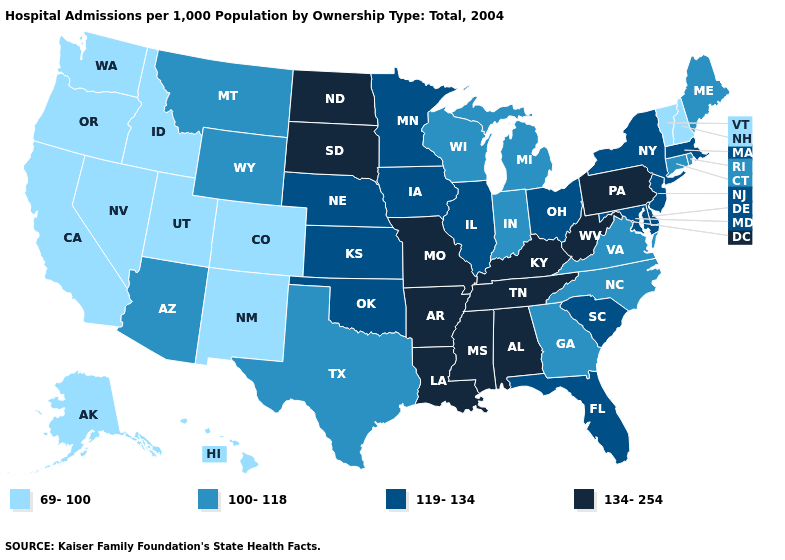Which states have the highest value in the USA?
Quick response, please. Alabama, Arkansas, Kentucky, Louisiana, Mississippi, Missouri, North Dakota, Pennsylvania, South Dakota, Tennessee, West Virginia. Which states have the lowest value in the West?
Short answer required. Alaska, California, Colorado, Hawaii, Idaho, Nevada, New Mexico, Oregon, Utah, Washington. Does Mississippi have the lowest value in the USA?
Short answer required. No. What is the highest value in states that border Oregon?
Answer briefly. 69-100. Which states have the highest value in the USA?
Write a very short answer. Alabama, Arkansas, Kentucky, Louisiana, Mississippi, Missouri, North Dakota, Pennsylvania, South Dakota, Tennessee, West Virginia. Is the legend a continuous bar?
Keep it brief. No. Among the states that border Wyoming , does Nebraska have the lowest value?
Keep it brief. No. What is the highest value in the USA?
Short answer required. 134-254. Name the states that have a value in the range 119-134?
Give a very brief answer. Delaware, Florida, Illinois, Iowa, Kansas, Maryland, Massachusetts, Minnesota, Nebraska, New Jersey, New York, Ohio, Oklahoma, South Carolina. What is the value of Ohio?
Be succinct. 119-134. What is the value of California?
Quick response, please. 69-100. Does Iowa have a lower value than Idaho?
Answer briefly. No. What is the lowest value in states that border Oregon?
Be succinct. 69-100. Which states have the highest value in the USA?
Short answer required. Alabama, Arkansas, Kentucky, Louisiana, Mississippi, Missouri, North Dakota, Pennsylvania, South Dakota, Tennessee, West Virginia. What is the lowest value in the USA?
Short answer required. 69-100. 